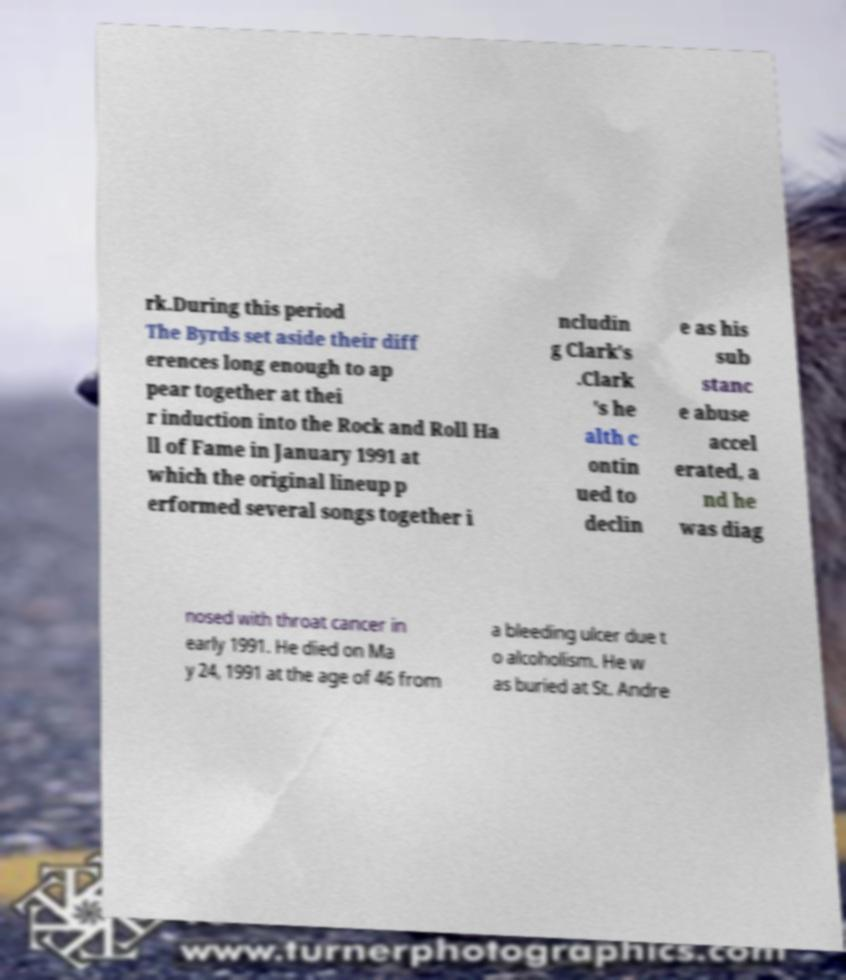Can you accurately transcribe the text from the provided image for me? rk.During this period The Byrds set aside their diff erences long enough to ap pear together at thei r induction into the Rock and Roll Ha ll of Fame in January 1991 at which the original lineup p erformed several songs together i ncludin g Clark's .Clark 's he alth c ontin ued to declin e as his sub stanc e abuse accel erated, a nd he was diag nosed with throat cancer in early 1991. He died on Ma y 24, 1991 at the age of 46 from a bleeding ulcer due t o alcoholism. He w as buried at St. Andre 